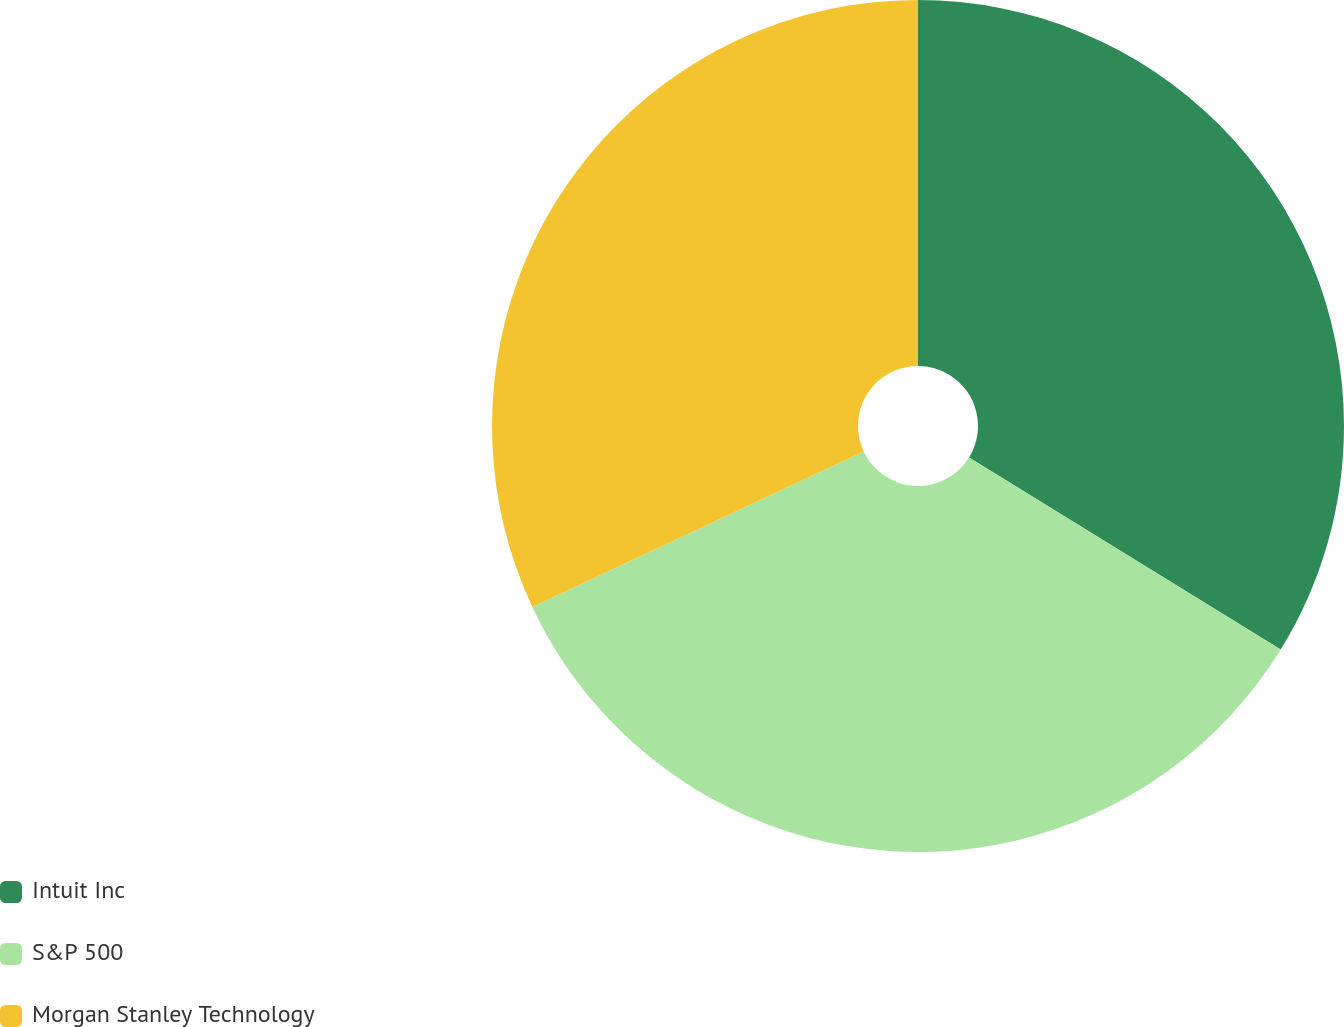<chart> <loc_0><loc_0><loc_500><loc_500><pie_chart><fcel>Intuit Inc<fcel>S&P 500<fcel>Morgan Stanley Technology<nl><fcel>33.79%<fcel>34.23%<fcel>31.98%<nl></chart> 